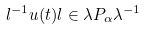<formula> <loc_0><loc_0><loc_500><loc_500>l ^ { - 1 } u ( t ) l \in \lambda P _ { \alpha } \lambda ^ { - 1 }</formula> 